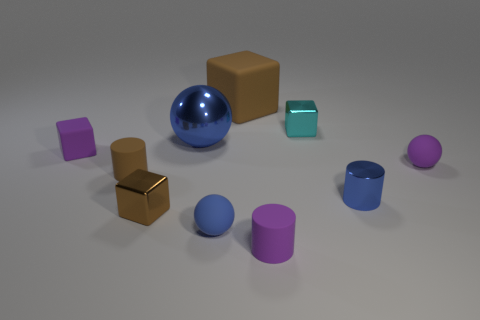There is another metallic thing that is the same color as the large metal thing; what is its shape?
Keep it short and to the point. Cylinder. How many red objects have the same shape as the tiny brown matte object?
Offer a very short reply. 0. There is a brown block that is the same material as the purple sphere; what size is it?
Offer a very short reply. Large. Do the blue shiny cylinder and the blue metallic sphere have the same size?
Make the answer very short. No. Are there any purple spheres?
Give a very brief answer. Yes. What is the size of the cylinder that is the same color as the metal ball?
Your answer should be very brief. Small. There is a object that is left of the brown rubber thing in front of the blue metallic thing that is on the left side of the purple cylinder; what is its size?
Give a very brief answer. Small. What number of small purple objects are the same material as the purple cube?
Give a very brief answer. 2. How many brown metallic objects are the same size as the brown cylinder?
Make the answer very short. 1. What is the material of the big object that is in front of the shiny cube on the right side of the small ball on the left side of the cyan thing?
Keep it short and to the point. Metal. 